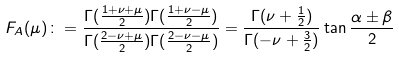Convert formula to latex. <formula><loc_0><loc_0><loc_500><loc_500>F _ { A } ( \mu ) \colon = \frac { \Gamma ( \frac { 1 + \nu + \mu } { 2 } ) \Gamma ( \frac { 1 + \nu - \mu } { 2 } ) } { \Gamma ( \frac { 2 - \nu + \mu } { 2 } ) \Gamma ( \frac { 2 - \nu - \mu } { 2 } ) } = \frac { \Gamma ( \nu + \frac { 1 } { 2 } ) } { \Gamma ( - \nu + \frac { 3 } { 2 } ) } \tan \frac { \alpha \pm \beta } { 2 }</formula> 